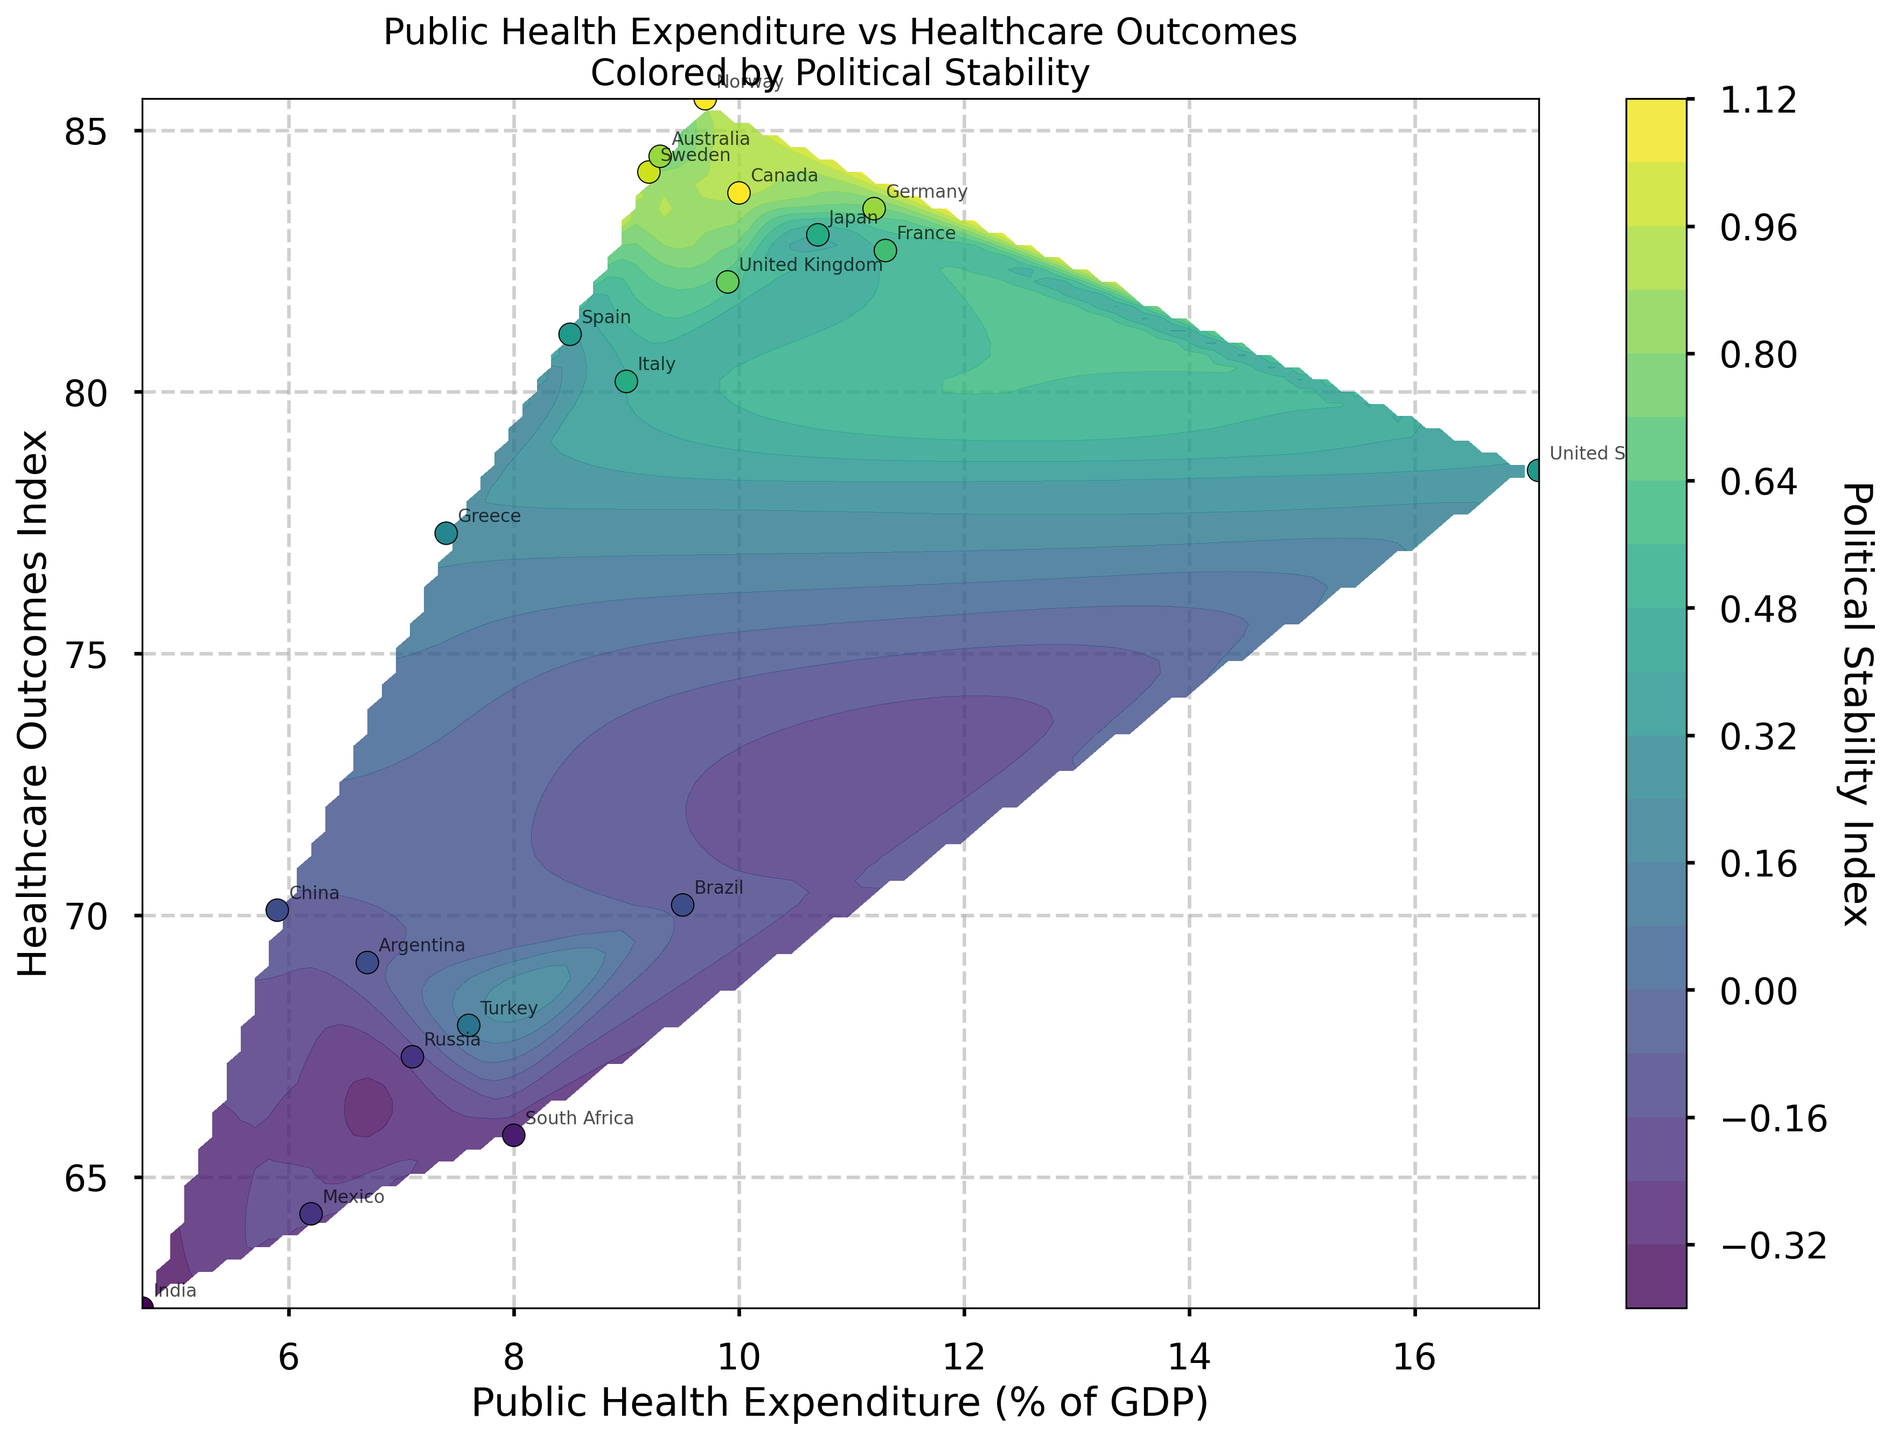What is the title of the plot? The title is usually located at the top of the figure. From the description, the title should be "Public Health Expenditure vs Healthcare Outcomes Colored by Political Stability".
Answer: Public Health Expenditure vs Healthcare Outcomes Colored by Political Stability Which country has the highest Public Health Expenditure (% of GDP)? The country with the highest Public Health Expenditure can be identified by looking at the x-axis and finding the farthest point to the right. According to the data, it is the United States with an expenditure of 17.1%.
Answer: United States How are the Public Health Expenditure and Healthcare Outcomes related in countries with a Political Stability Index greater than 0.5? To answer this, we focus on the countries with a Political Stability Index greater than 0.5, indicated by darker colors in the plot. These points generally lie high on the Healthcare Outcomes Index and vary across the x-axis, suggesting that higher stability correlates with better healthcare outcomes, regardless of expenditure.
Answer: Generally, positively related Which country has the best Healthcare Outcomes Index, and what is its Public Health Expenditure (% of GDP)? The best Healthcare Outcomes Index corresponds to the highest point on the y-axis. According to the data, Norway has the best Healthcare Outcomes Index of 85.6 with a Public Health Expenditure of 9.7%.
Answer: Norway, 9.7% Is there any visible pattern in the relationship between Public Health Expenditure and Healthcare Outcomes for the various countries? By examining the overall distribution of points and the contour lines, we can infer any trends. The contours and scatter points suggest that higher Public Health Expenditure does not linearly correlate with higher Healthcare Outcomes; however, countries with higher political stability seem to have better healthcare outcomes.
Answer: Mixed pattern, not linear Which country with a negative Political Stability Index has the highest Healthcare Outcomes Index? Points corresponding to negative Political Stability Index are shown with less intense colors. Among these, China has the highest Healthcare Outcomes Index of 70.1%.
Answer: China Compare the Healthcare Outcomes Index of Germany and France. Which one is higher, and by how much? Locate Germany and France on the plot based on their annotations. Germany has an index of 83.5, and France has 82.7. The difference is calculated by subtracting the smaller value from the larger one.
Answer: Germany, by 0.8 What is the trend of Political Stability Index with respect to both Public Health Expenditure and Healthcare Outcomes as observed in the contour plot? Observing the color gradients from the contours, we can note that higher Political Stability Index is generally observed in regions with higher Healthcare Outcomes and a moderate range of Public Health Expenditure.
Answer: Higher stability in areas of better outcomes and moderate expenditure How does the Political Stability Index of India compare to that of Brazil? Look at the Political Stability Index by observing the colors of the points representing India and Brazil. India has an index of -0.4, while Brazil has -0.1. Brazil's stability is higher.
Answer: Brazil is higher Which country with a Public Health Expenditure below 8% has the highest Healthcare Outcomes Index? Identify the countries below 8% on the x-axis, then look for the highest y-axis value among these. According to the data, Spain has the highest Healthcare Outcomes Index (81.1) among countries with a Public Health Expenditure below 8%.
Answer: Spain 